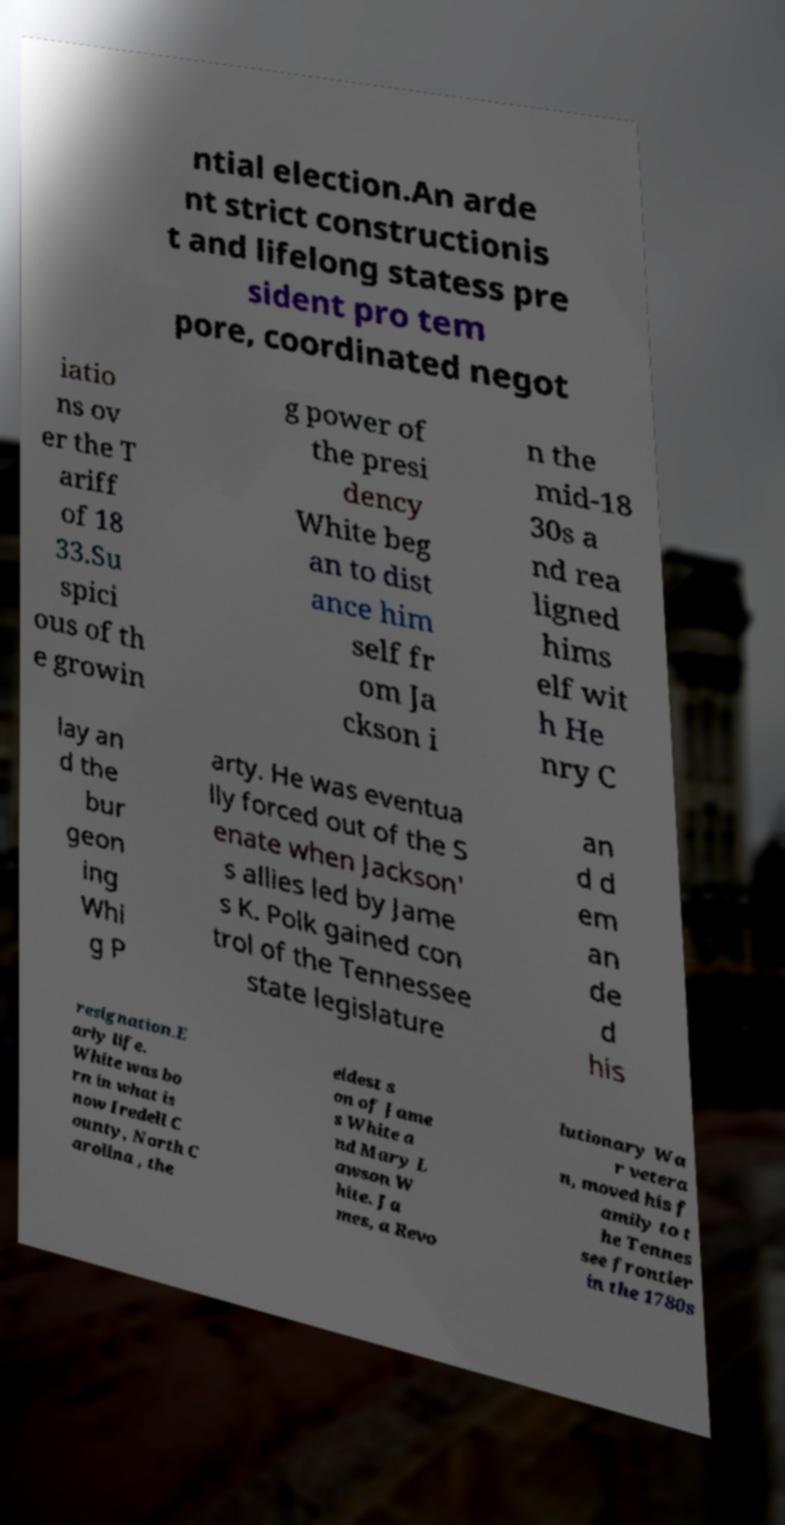For documentation purposes, I need the text within this image transcribed. Could you provide that? ntial election.An arde nt strict constructionis t and lifelong statess pre sident pro tem pore, coordinated negot iatio ns ov er the T ariff of 18 33.Su spici ous of th e growin g power of the presi dency White beg an to dist ance him self fr om Ja ckson i n the mid-18 30s a nd rea ligned hims elf wit h He nry C lay an d the bur geon ing Whi g P arty. He was eventua lly forced out of the S enate when Jackson' s allies led by Jame s K. Polk gained con trol of the Tennessee state legislature an d d em an de d his resignation.E arly life. White was bo rn in what is now Iredell C ounty, North C arolina , the eldest s on of Jame s White a nd Mary L awson W hite. Ja mes, a Revo lutionary Wa r vetera n, moved his f amily to t he Tennes see frontier in the 1780s 